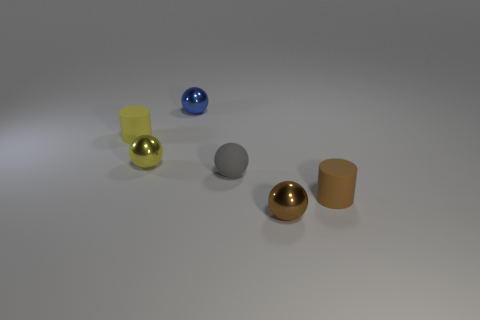Subtract all small matte spheres. How many spheres are left? 3 Add 2 small shiny cylinders. How many objects exist? 8 Subtract all brown cylinders. How many cylinders are left? 1 Subtract all balls. How many objects are left? 2 Subtract 0 cyan cylinders. How many objects are left? 6 Subtract 1 cylinders. How many cylinders are left? 1 Subtract all yellow balls. Subtract all cyan cylinders. How many balls are left? 3 Subtract all blue cylinders. How many gray balls are left? 1 Subtract all yellow spheres. Subtract all small brown shiny things. How many objects are left? 4 Add 3 yellow matte objects. How many yellow matte objects are left? 4 